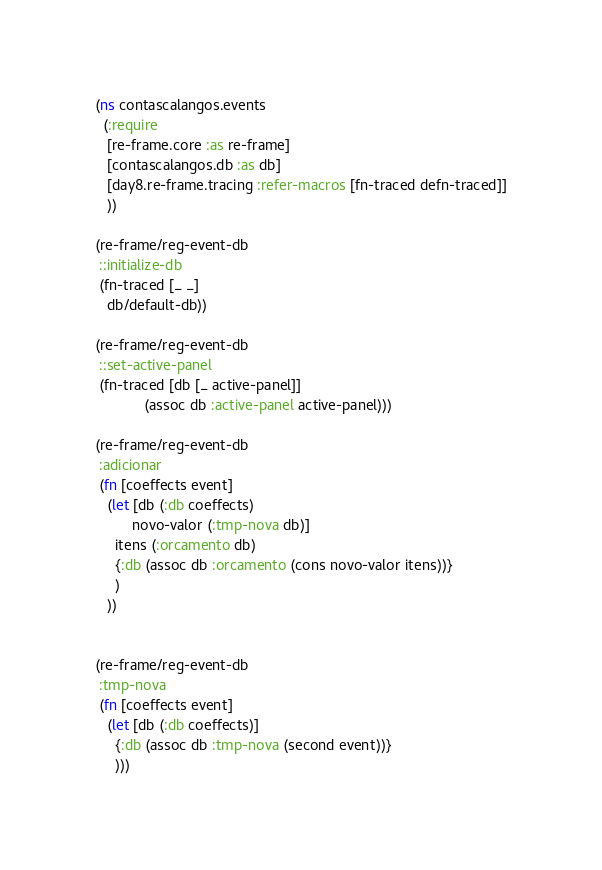<code> <loc_0><loc_0><loc_500><loc_500><_Clojure_>(ns contascalangos.events
  (:require
   [re-frame.core :as re-frame]
   [contascalangos.db :as db]
   [day8.re-frame.tracing :refer-macros [fn-traced defn-traced]]
   ))

(re-frame/reg-event-db
 ::initialize-db
 (fn-traced [_ _]
   db/default-db))

(re-frame/reg-event-db
 ::set-active-panel
 (fn-traced [db [_ active-panel]]
            (assoc db :active-panel active-panel)))

(re-frame/reg-event-db
 :adicionar
 (fn [coeffects event]
   (let [db (:db coeffects)
         novo-valor (:tmp-nova db)]
     itens (:orcamento db)
     {:db (assoc db :orcamento (cons novo-valor itens))}
     )
   ))


(re-frame/reg-event-db
 :tmp-nova
 (fn [coeffects event]
   (let [db (:db coeffects)]
     {:db (assoc db :tmp-nova (second event))}
     )))
</code> 